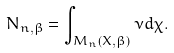Convert formula to latex. <formula><loc_0><loc_0><loc_500><loc_500>N _ { n , \beta } = \int _ { M _ { n } ( X , \beta ) } \nu d \chi .</formula> 